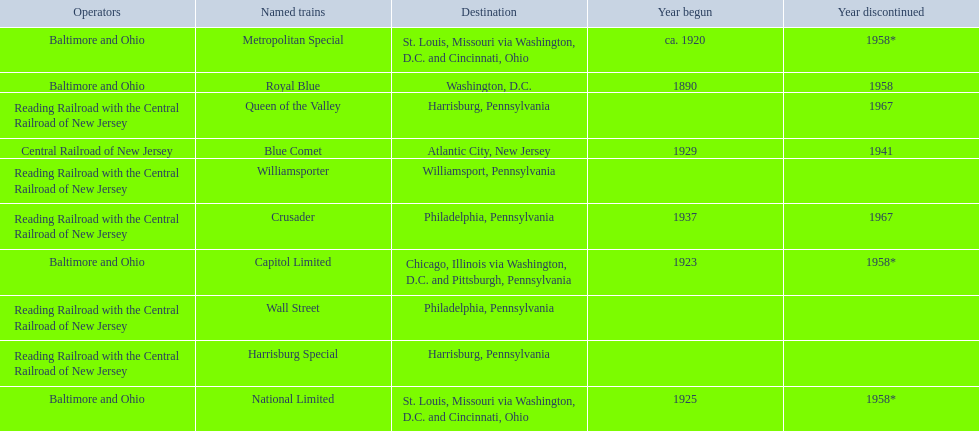Which of the trains are operated by reading railroad with the central railroad of new jersey? Crusader, Harrisburg Special, Queen of the Valley, Wall Street, Williamsporter. Of these trains, which of them had a destination of philadelphia, pennsylvania? Crusader, Wall Street. Write the full table. {'header': ['Operators', 'Named trains', 'Destination', 'Year begun', 'Year discontinued'], 'rows': [['Baltimore and Ohio', 'Metropolitan Special', 'St. Louis, Missouri via Washington, D.C. and Cincinnati, Ohio', 'ca. 1920', '1958*'], ['Baltimore and Ohio', 'Royal Blue', 'Washington, D.C.', '1890', '1958'], ['Reading Railroad with the Central Railroad of New Jersey', 'Queen of the Valley', 'Harrisburg, Pennsylvania', '', '1967'], ['Central Railroad of New Jersey', 'Blue Comet', 'Atlantic City, New Jersey', '1929', '1941'], ['Reading Railroad with the Central Railroad of New Jersey', 'Williamsporter', 'Williamsport, Pennsylvania', '', ''], ['Reading Railroad with the Central Railroad of New Jersey', 'Crusader', 'Philadelphia, Pennsylvania', '1937', '1967'], ['Baltimore and Ohio', 'Capitol Limited', 'Chicago, Illinois via Washington, D.C. and Pittsburgh, Pennsylvania', '1923', '1958*'], ['Reading Railroad with the Central Railroad of New Jersey', 'Wall Street', 'Philadelphia, Pennsylvania', '', ''], ['Reading Railroad with the Central Railroad of New Jersey', 'Harrisburg Special', 'Harrisburg, Pennsylvania', '', ''], ['Baltimore and Ohio', 'National Limited', 'St. Louis, Missouri via Washington, D.C. and Cincinnati, Ohio', '1925', '1958*']]} Out of these two trains, which one is discontinued? Crusader. 